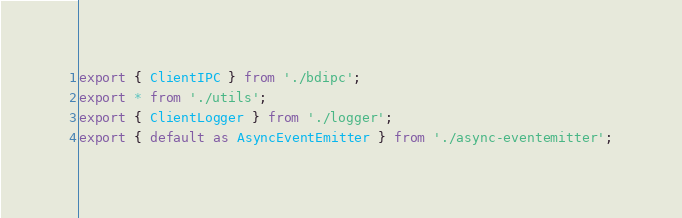<code> <loc_0><loc_0><loc_500><loc_500><_JavaScript_>export { ClientIPC } from './bdipc';
export * from './utils';
export { ClientLogger } from './logger';
export { default as AsyncEventEmitter } from './async-eventemitter';
</code> 